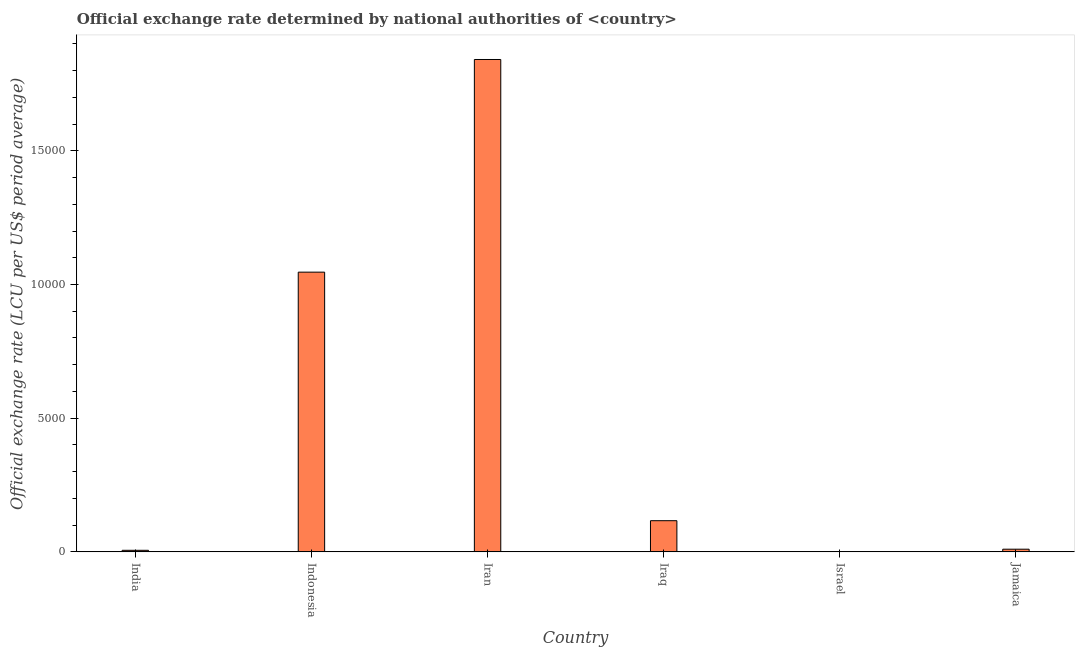Does the graph contain grids?
Make the answer very short. No. What is the title of the graph?
Offer a terse response. Official exchange rate determined by national authorities of <country>. What is the label or title of the X-axis?
Provide a succinct answer. Country. What is the label or title of the Y-axis?
Make the answer very short. Official exchange rate (LCU per US$ period average). What is the official exchange rate in Iran?
Your response must be concise. 1.84e+04. Across all countries, what is the maximum official exchange rate?
Offer a terse response. 1.84e+04. Across all countries, what is the minimum official exchange rate?
Offer a terse response. 3.61. In which country was the official exchange rate maximum?
Your response must be concise. Iran. In which country was the official exchange rate minimum?
Your response must be concise. Israel. What is the sum of the official exchange rate?
Keep it short and to the point. 3.02e+04. What is the difference between the official exchange rate in India and Indonesia?
Make the answer very short. -1.04e+04. What is the average official exchange rate per country?
Offer a terse response. 5034.02. What is the median official exchange rate?
Provide a short and direct response. 633.12. What is the ratio of the official exchange rate in Indonesia to that in Israel?
Offer a terse response. 2897.24. Is the difference between the official exchange rate in Iraq and Jamaica greater than the difference between any two countries?
Make the answer very short. No. What is the difference between the highest and the second highest official exchange rate?
Give a very brief answer. 7953.21. What is the difference between the highest and the lowest official exchange rate?
Your answer should be very brief. 1.84e+04. In how many countries, is the official exchange rate greater than the average official exchange rate taken over all countries?
Your answer should be very brief. 2. Are all the bars in the graph horizontal?
Provide a succinct answer. No. How many countries are there in the graph?
Keep it short and to the point. 6. Are the values on the major ticks of Y-axis written in scientific E-notation?
Your answer should be very brief. No. What is the Official exchange rate (LCU per US$ period average) in India?
Make the answer very short. 58.6. What is the Official exchange rate (LCU per US$ period average) in Indonesia?
Your answer should be very brief. 1.05e+04. What is the Official exchange rate (LCU per US$ period average) of Iran?
Your response must be concise. 1.84e+04. What is the Official exchange rate (LCU per US$ period average) of Iraq?
Provide a short and direct response. 1166. What is the Official exchange rate (LCU per US$ period average) of Israel?
Your response must be concise. 3.61. What is the Official exchange rate (LCU per US$ period average) in Jamaica?
Give a very brief answer. 100.24. What is the difference between the Official exchange rate (LCU per US$ period average) in India and Indonesia?
Your answer should be very brief. -1.04e+04. What is the difference between the Official exchange rate (LCU per US$ period average) in India and Iran?
Offer a terse response. -1.84e+04. What is the difference between the Official exchange rate (LCU per US$ period average) in India and Iraq?
Offer a very short reply. -1107.4. What is the difference between the Official exchange rate (LCU per US$ period average) in India and Israel?
Offer a very short reply. 54.99. What is the difference between the Official exchange rate (LCU per US$ period average) in India and Jamaica?
Provide a succinct answer. -41.64. What is the difference between the Official exchange rate (LCU per US$ period average) in Indonesia and Iran?
Your answer should be very brief. -7953.21. What is the difference between the Official exchange rate (LCU per US$ period average) in Indonesia and Iraq?
Your answer should be compact. 9295.24. What is the difference between the Official exchange rate (LCU per US$ period average) in Indonesia and Israel?
Your response must be concise. 1.05e+04. What is the difference between the Official exchange rate (LCU per US$ period average) in Indonesia and Jamaica?
Provide a succinct answer. 1.04e+04. What is the difference between the Official exchange rate (LCU per US$ period average) in Iran and Iraq?
Your response must be concise. 1.72e+04. What is the difference between the Official exchange rate (LCU per US$ period average) in Iran and Israel?
Your response must be concise. 1.84e+04. What is the difference between the Official exchange rate (LCU per US$ period average) in Iran and Jamaica?
Provide a short and direct response. 1.83e+04. What is the difference between the Official exchange rate (LCU per US$ period average) in Iraq and Israel?
Offer a terse response. 1162.39. What is the difference between the Official exchange rate (LCU per US$ period average) in Iraq and Jamaica?
Make the answer very short. 1065.76. What is the difference between the Official exchange rate (LCU per US$ period average) in Israel and Jamaica?
Keep it short and to the point. -96.63. What is the ratio of the Official exchange rate (LCU per US$ period average) in India to that in Indonesia?
Your answer should be very brief. 0.01. What is the ratio of the Official exchange rate (LCU per US$ period average) in India to that in Iran?
Your response must be concise. 0. What is the ratio of the Official exchange rate (LCU per US$ period average) in India to that in Iraq?
Keep it short and to the point. 0.05. What is the ratio of the Official exchange rate (LCU per US$ period average) in India to that in Israel?
Offer a very short reply. 16.23. What is the ratio of the Official exchange rate (LCU per US$ period average) in India to that in Jamaica?
Provide a short and direct response. 0.58. What is the ratio of the Official exchange rate (LCU per US$ period average) in Indonesia to that in Iran?
Your response must be concise. 0.57. What is the ratio of the Official exchange rate (LCU per US$ period average) in Indonesia to that in Iraq?
Your answer should be compact. 8.97. What is the ratio of the Official exchange rate (LCU per US$ period average) in Indonesia to that in Israel?
Your response must be concise. 2897.24. What is the ratio of the Official exchange rate (LCU per US$ period average) in Indonesia to that in Jamaica?
Give a very brief answer. 104.36. What is the ratio of the Official exchange rate (LCU per US$ period average) in Iran to that in Iraq?
Provide a short and direct response. 15.79. What is the ratio of the Official exchange rate (LCU per US$ period average) in Iran to that in Israel?
Provide a short and direct response. 5099.88. What is the ratio of the Official exchange rate (LCU per US$ period average) in Iran to that in Jamaica?
Provide a short and direct response. 183.7. What is the ratio of the Official exchange rate (LCU per US$ period average) in Iraq to that in Israel?
Provide a short and direct response. 322.92. What is the ratio of the Official exchange rate (LCU per US$ period average) in Iraq to that in Jamaica?
Provide a short and direct response. 11.63. What is the ratio of the Official exchange rate (LCU per US$ period average) in Israel to that in Jamaica?
Your answer should be compact. 0.04. 